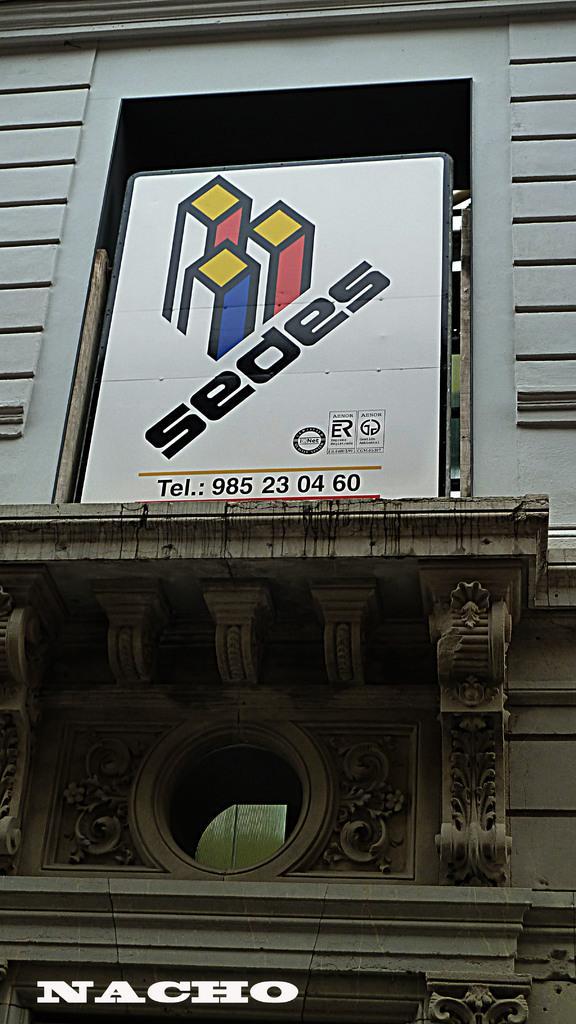In one or two sentences, can you explain what this image depicts? In this picture we can see the wall and a board with some text on it. 